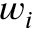Convert formula to latex. <formula><loc_0><loc_0><loc_500><loc_500>w _ { i }</formula> 